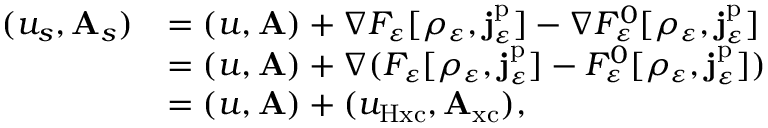Convert formula to latex. <formula><loc_0><loc_0><loc_500><loc_500>\begin{array} { r l } { ( u _ { s } , A _ { s } ) } & { = ( u , A ) + \nabla F _ { \varepsilon } [ \rho _ { \varepsilon } , j _ { \varepsilon } ^ { p } ] - \nabla F _ { \varepsilon } ^ { 0 } [ \rho _ { \varepsilon } , j _ { \varepsilon } ^ { p } ] } \\ & { = ( u , A ) + \nabla ( F _ { \varepsilon } [ \rho _ { \varepsilon } , j _ { \varepsilon } ^ { p } ] - F _ { \varepsilon } ^ { 0 } [ \rho _ { \varepsilon } , j _ { \varepsilon } ^ { p } ] ) } \\ & { = ( u , A ) + ( u _ { H x c } , A _ { x c } ) , } \end{array}</formula> 